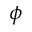Convert formula to latex. <formula><loc_0><loc_0><loc_500><loc_500>\phi</formula> 